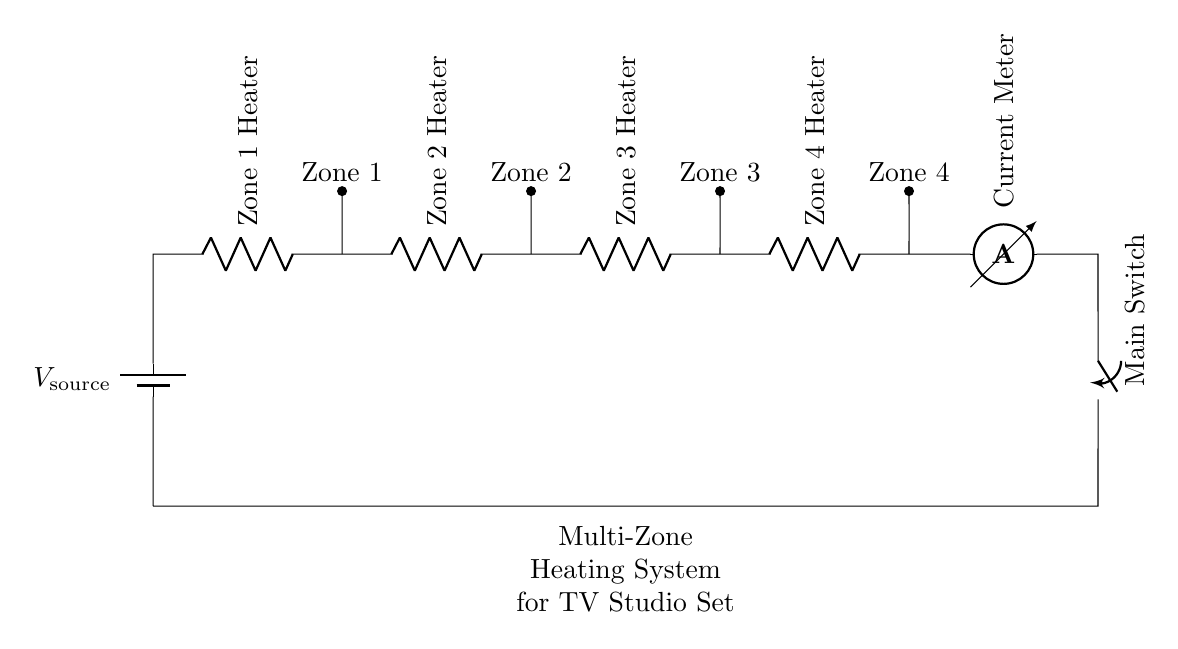What is the type of circuit shown? The circuit is a series circuit, as indicated by the sequential arrangement of components connected from the source through each heater to the ammeter.
Answer: Series circuit How many heaters are in the circuit? The diagram shows four heaters connected in series, each labeled as Zone 1, Zone 2, Zone 3, and Zone 4.
Answer: Four What does the ammeter measure in this circuit? The ammeter measures the current flowing through the circuit, which is constant in a series configuration due to all components being in line.
Answer: Current What happens if the main switch is off? If the main switch is off, it breaks the circuit, preventing current from flowing to any of the heaters, effectively turning off the entire heating system.
Answer: No current Which component controls the entire system? The main switch controls the overall operation of the heating system by allowing or interrupting current flow through the entire circuit.
Answer: Main switch How is each zone connected to the circuit? Each zone heater is connected in series to the other components, meaning that they are all part of a single path for current to flow.
Answer: In series What effect does adding another heater have in this circuit? Adding another heater in series would increase the total resistance of the circuit and decrease the current flowing through all heaters, as they share the source voltage.
Answer: Decrease current 